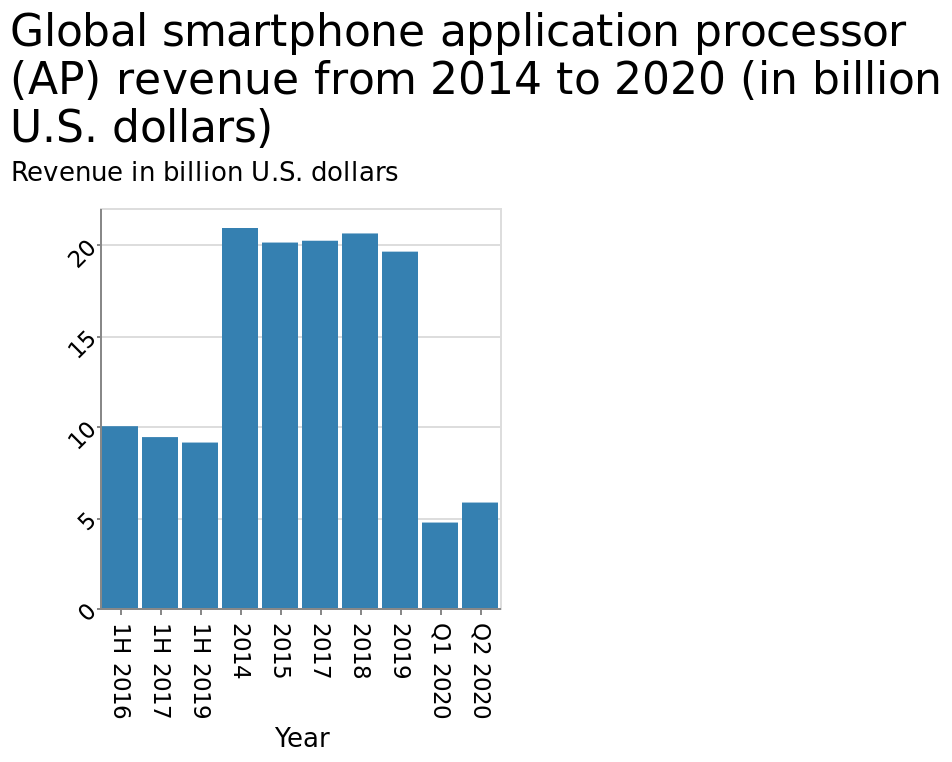<image>
please summary the statistics and relations of the chart 2014 to 2019 saw the most revenue with the highest being in 2014 at 21 billion. The revenue in the quarters of 2020 if continued into 3rd and 4th i estimate will be larger than the combined 2019 showing a continued trend. Will the combined revenue of the quarters in 2020 exceed the revenue of 2019? Yes, it is estimated that the combined revenue of the quarters in 2020 will be larger than the revenue of 2019. What was the revenue trend between 2014 and 2019? The revenue trend between 2014 and 2019 was generally increasing, with the highest revenue recorded in 2014. Was the revenue trend between 2014 and 2019 generally decreasing, with the highest revenue recorded in 2014? No.The revenue trend between 2014 and 2019 was generally increasing, with the highest revenue recorded in 2014. 